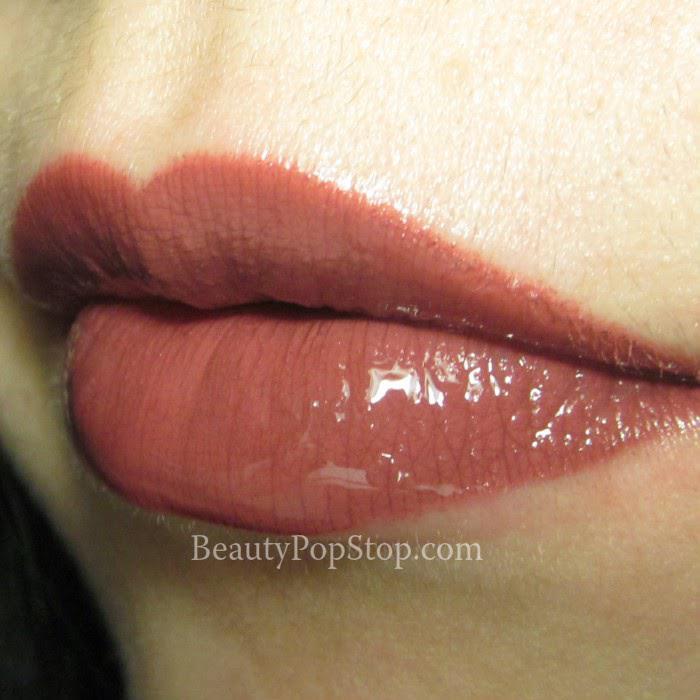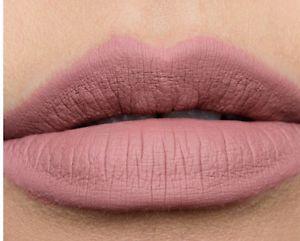The first image is the image on the left, the second image is the image on the right. Given the left and right images, does the statement "The right image contains human lips with lipstick on them." hold true? Answer yes or no. Yes. The first image is the image on the left, the second image is the image on the right. For the images shown, is this caption "A lipstick swatch is shown on a person's lip in both images." true? Answer yes or no. Yes. 